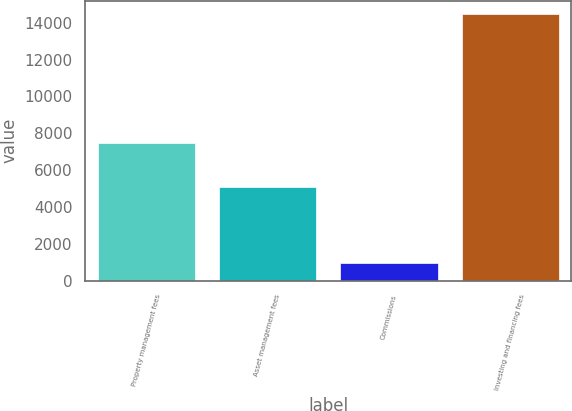<chart> <loc_0><loc_0><loc_500><loc_500><bar_chart><fcel>Property management fees<fcel>Asset management fees<fcel>Commissions<fcel>Investing and financing fees<nl><fcel>7496<fcel>5106<fcel>947<fcel>14470<nl></chart> 